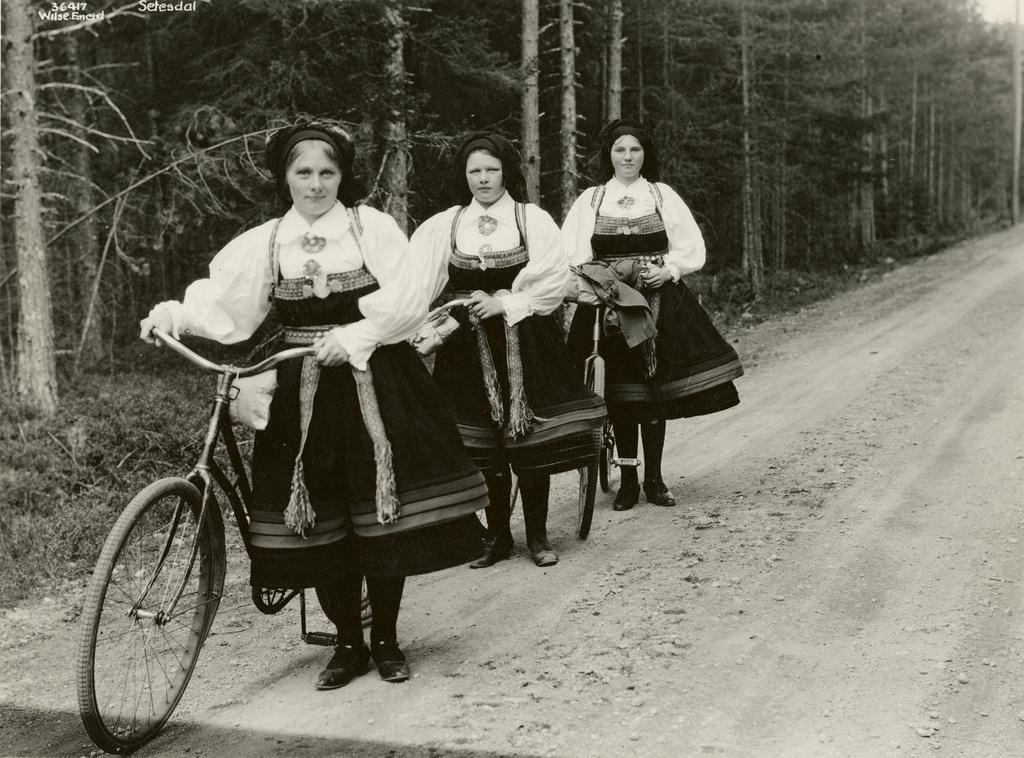Can you describe this image briefly? This is a black and white picture. Here we can see trees. We can see three women standing near to the bicycles. They all are in a same attire. 